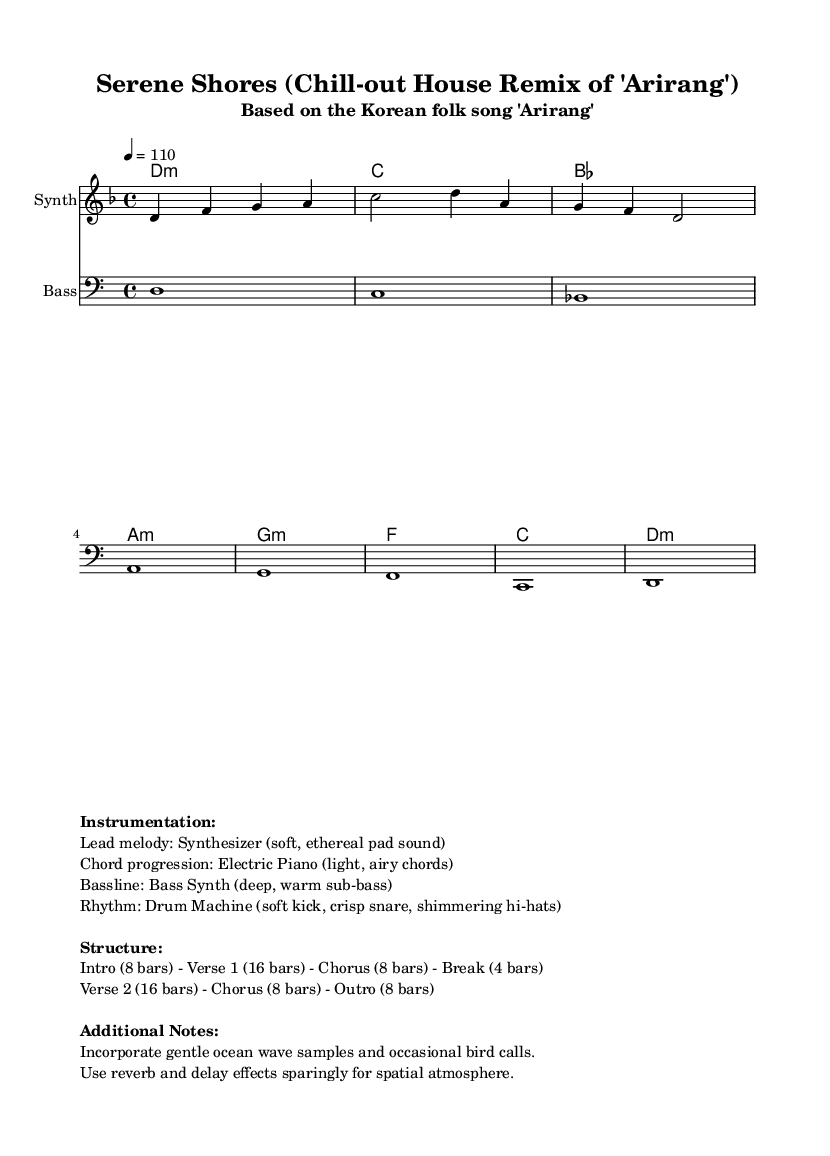What is the key signature of this music? The key signature is D minor, which has one flat. This is determined by looking at the global section of the LilyPond code, where it is stated \key d \minor.
Answer: D minor What is the time signature of this music? The time signature is 4/4, which means there are four beats in each measure and each beat is a quarter note. This is also found in the global section of the LilyPond code, stated as \time 4/4.
Answer: 4/4 What is the tempo marked in this music? The tempo is marked as 110 beats per minute. This is specified in the global section of the code where it is stated \tempo 4 = 110, indicating the tempo for the piece.
Answer: 110 How many bars are in the Intro section? The Intro section consists of 8 bars, as noted in the structure outline provided in the markup section of the score.
Answer: 8 bars What instruments are used in this piece? The instruments used are Synthesizer, Electric Piano, Bass Synth, and Drum Machine. This information is detailed in the instrumentation section of the markup provided in the code.
Answer: Synthesizer, Electric Piano, Bass Synth, Drum Machine What is the chord for the first bar? The chord for the first bar is D minor, which can be identified from the harmonies section of the code where it is stated d1:m for the first chord.
Answer: D minor What type of sound is the lead melody instrument meant to have? The lead melody instrument, the Synthesizer, is meant to have a soft, ethereal pad sound. This description is clearly outlined in the instrumentation notes in the markup section.
Answer: Soft, ethereal pad sound 